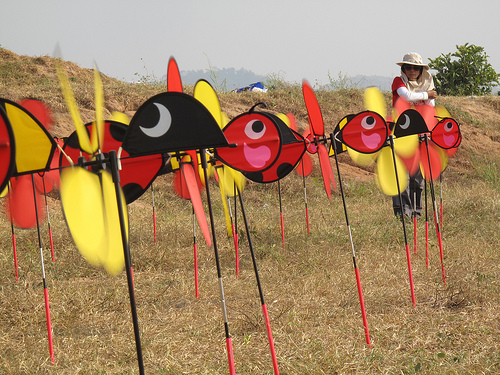<image>
Can you confirm if the woman is behind the fan? Yes. From this viewpoint, the woman is positioned behind the fan, with the fan partially or fully occluding the woman. Where is the red fish in relation to the women? Is it behind the women? No. The red fish is not behind the women. From this viewpoint, the red fish appears to be positioned elsewhere in the scene. 